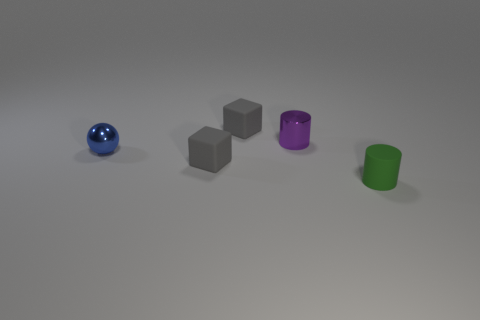Is there a green matte thing that has the same size as the green cylinder?
Offer a very short reply. No. There is a small cylinder that is the same material as the small ball; what is its color?
Offer a very short reply. Purple. There is a cylinder on the left side of the matte cylinder; what number of gray blocks are in front of it?
Your answer should be very brief. 1. The small thing that is both in front of the ball and left of the purple metal object is made of what material?
Provide a succinct answer. Rubber. Is the shape of the small metal object on the right side of the tiny blue shiny thing the same as  the green rubber thing?
Your answer should be very brief. Yes. Are there fewer small purple shiny things than large purple spheres?
Provide a short and direct response. No. How many blocks are the same color as the tiny metal cylinder?
Provide a succinct answer. 0. Does the tiny ball have the same color as the cylinder that is behind the tiny green thing?
Your response must be concise. No. Is the number of green rubber cylinders greater than the number of small gray balls?
Give a very brief answer. Yes. There is another rubber thing that is the same shape as the purple object; what size is it?
Provide a short and direct response. Small. 